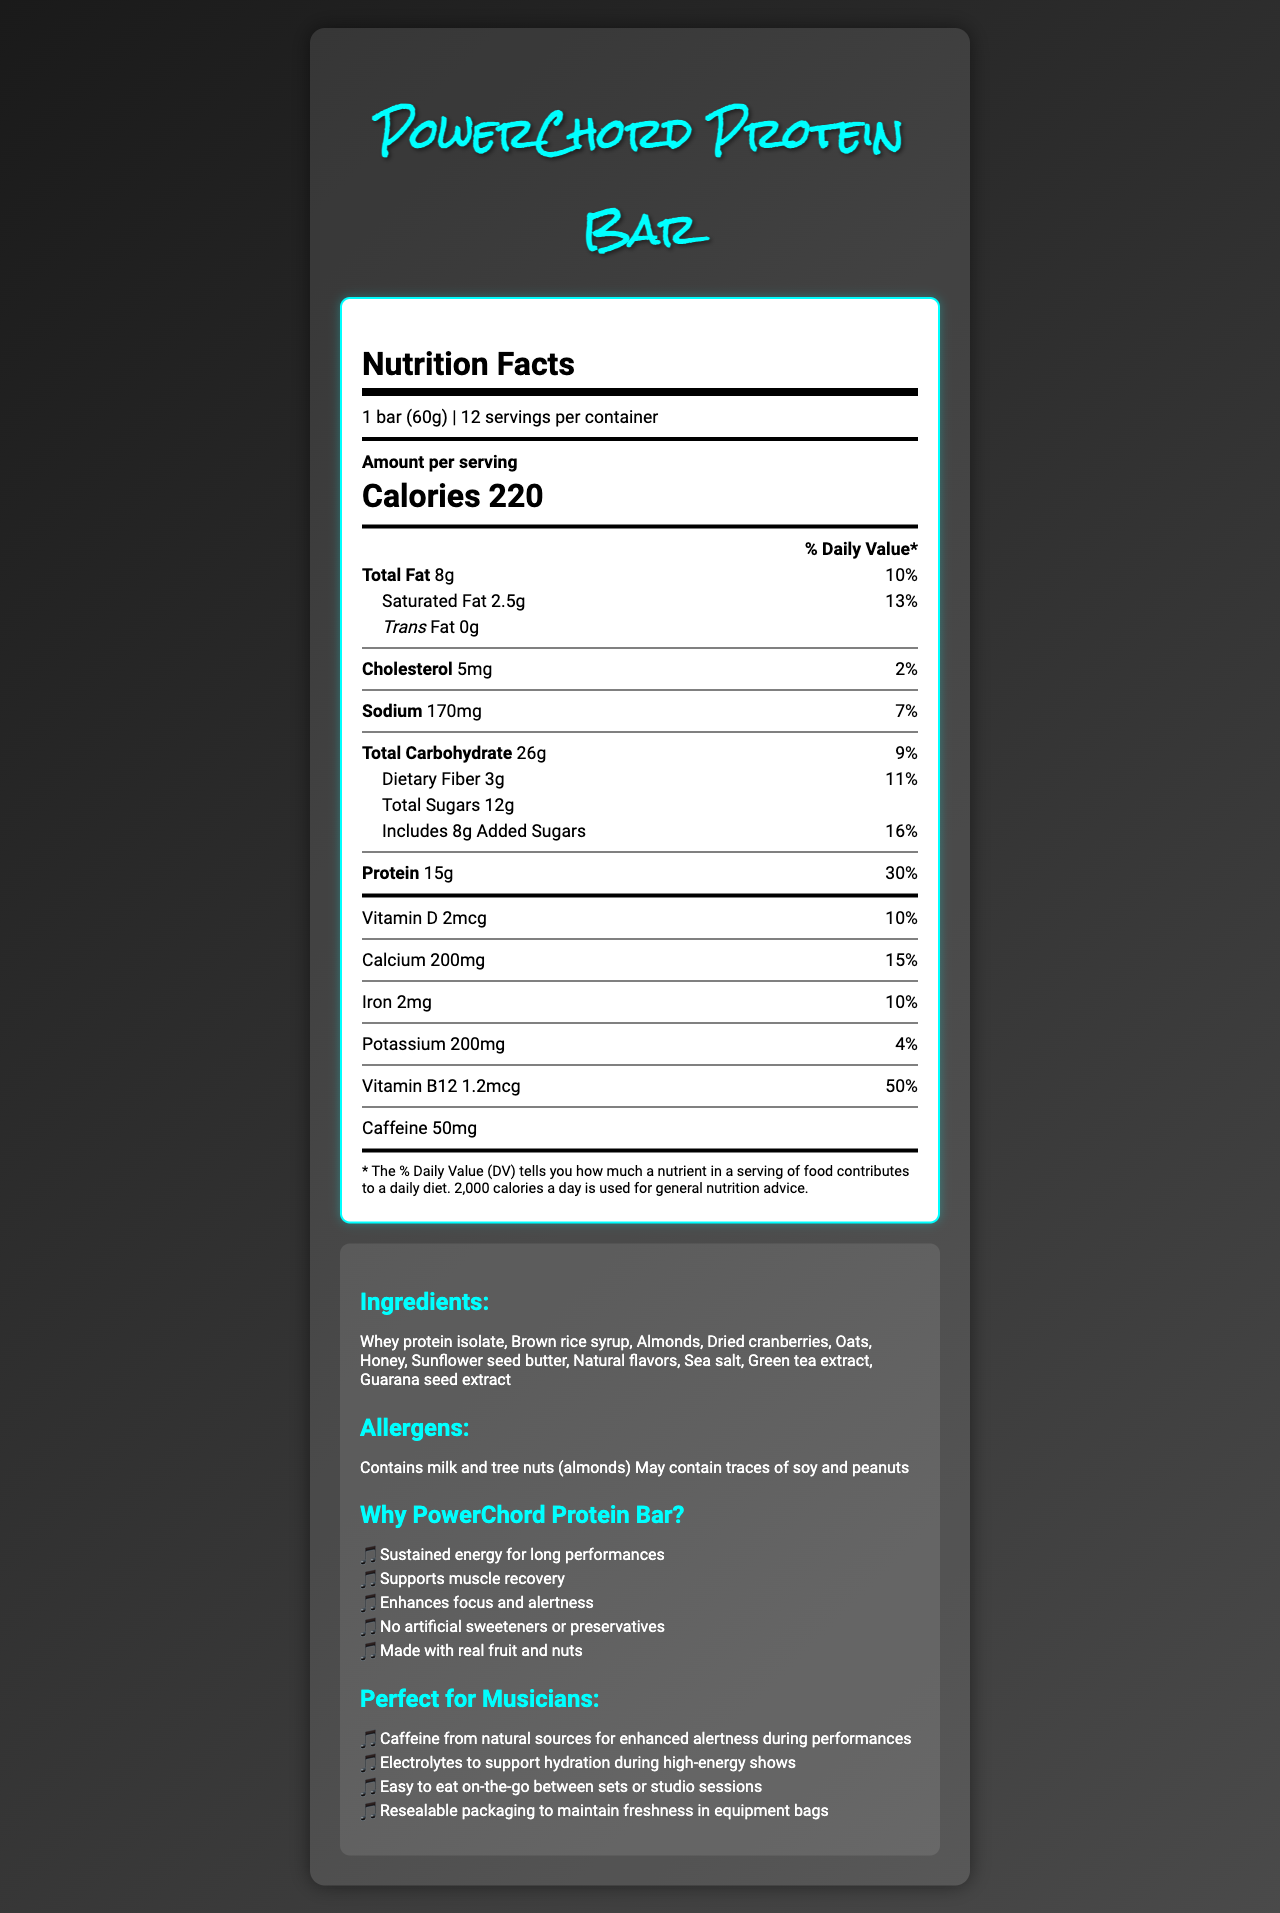what is the serving size of the PowerChord Protein Bar? The serving size is clearly listed at the top of the Nutrition Facts section of the document: "1 bar (60g)".
Answer: 1 bar (60g) how many calories are in one serving of the PowerChord Protein Bar? The calories per serving are prominently displayed in large font: "Calories 220".
Answer: 220 calories what is the amount of protein per serving? The amount of protein per serving is listed under the "Protein" section: "15g".
Answer: 15g how much saturated fat is in one bar? The amount of saturated fat per serving is listed under the "Saturated Fat" section: "2.5g".
Answer: 2.5g how much vitamin B12 does the PowerChord Protein Bar contain? The amount of vitamin B12 is listed near the bottom of the Nutrition Facts section: "Vitamin B12 1.2mcg".
Answer: 1.2mcg which ingredient is NOT in the PowerChord Protein Bar? A. Almonds B. Peanuts C. Honey The ingredients list includes "Almonds" and "Honey," but not "Peanuts."
Answer: B. Peanuts what percent of daily value of calcium does one bar provide? A. 10% B. 15% C. 20% The daily value percentage of calcium is listed as "15%".
Answer: B. 15% does the PowerChord Protein Bar contain any trans fat? The amount of trans fat is listed as "0g," indicating there is no trans fat in the bar.
Answer: No is the PowerChord Protein Bar suitable for someone with a peanut allergy? The allergen information mentions that it "May contain traces of soy and peanuts."
Answer: No describe the main idea of the document. The document is divided into sections that comprehensively detail the PowerChord Protein Bar's nutrition facts, including its ingredients, allergen information, and benefits specifically tailored for musicians and performers. The main idea is to present all relevant information to potential consumers in an organized and visually appealing manner.
Answer: The document provides detailed nutritional information about the PowerChord Protein Bar, highlighting its nutritional content, ingredients, allergens, marketing claims, and musician-specific features. how much caffeine is in one serving? The amount of caffeine is listed at the bottom of the Nutrition Facts section: "Caffeine 50mg".
Answer: 50mg what is the daily value percentage of added sugars? The daily value percentage for added sugars is listed as "16%".
Answer: 16% how many dietary fibers are in one serving? The amount of dietary fiber per serving is listed under the "Dietary Fiber" section: "3g".
Answer: 3g what are the marketing claims made about the PowerChord Protein Bar? The marketing claims are listed in the "Why PowerChord Protein Bar?" section.
Answer: Sustained energy for long performances, Supports muscle recovery, Enhances focus and alertness, No artificial sweeteners or preservatives, Made with real fruit and nuts what are the musician-specific features of the bar? The musician-specific features are listed in the "Perfect for Musicians" section.
Answer: Caffeine from natural sources for enhanced alertness during performances, Electrolytes to support hydration during high-energy shows, Easy to eat on-the-go between sets or studio sessions, Resealable packaging to maintain freshness in equipment bags what are the main allergens found in this product? The main allergens are listed under the "Allergens" section: "Contains milk and tree nuts (almonds)".
Answer: Contains milk and tree nuts (almonds) what is the main ingredient of the PowerChord Protein Bar? The document lists several ingredients without specifying which is the main ingredient. Therefore, additional information would be required to answer this.
Answer: Cannot be determined 